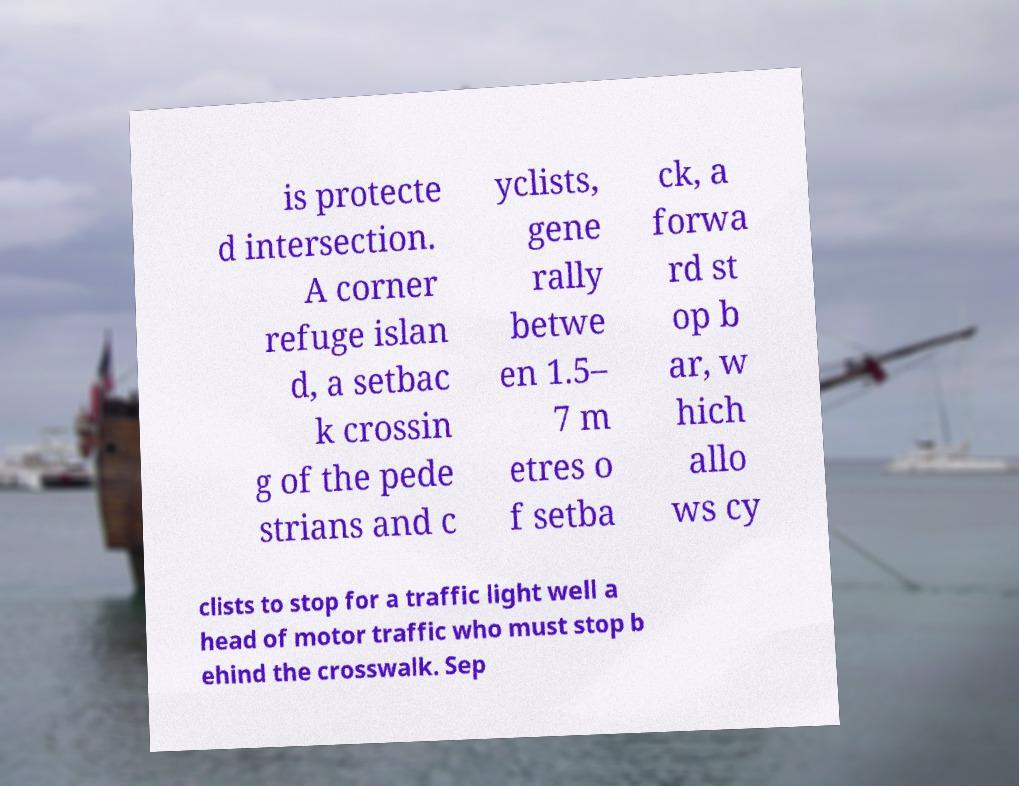Please read and relay the text visible in this image. What does it say? is protecte d intersection. A corner refuge islan d, a setbac k crossin g of the pede strians and c yclists, gene rally betwe en 1.5– 7 m etres o f setba ck, a forwa rd st op b ar, w hich allo ws cy clists to stop for a traffic light well a head of motor traffic who must stop b ehind the crosswalk. Sep 